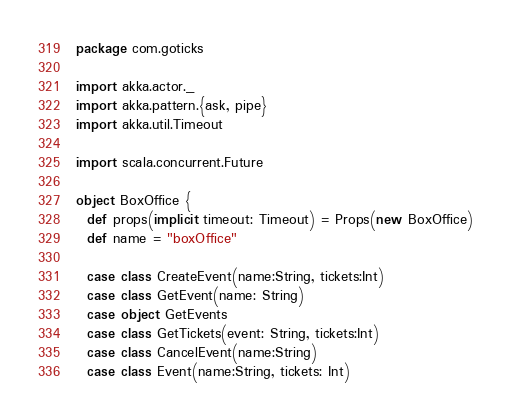Convert code to text. <code><loc_0><loc_0><loc_500><loc_500><_Scala_>package com.goticks

import akka.actor._
import akka.pattern.{ask, pipe}
import akka.util.Timeout

import scala.concurrent.Future

object BoxOffice {
  def props(implicit timeout: Timeout) = Props(new BoxOffice)
  def name = "boxOffice"

  case class CreateEvent(name:String, tickets:Int)
  case class GetEvent(name: String)
  case object GetEvents
  case class GetTickets(event: String, tickets:Int)
  case class CancelEvent(name:String)
  case class Event(name:String, tickets: Int)</code> 